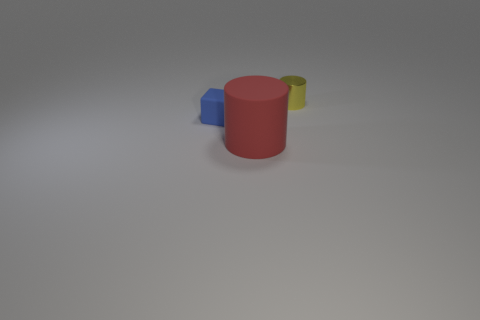What shape is the small thing in front of the small object to the right of the rubber object that is right of the blue block?
Provide a succinct answer. Cube. Is there another tiny yellow thing that has the same material as the small yellow thing?
Ensure brevity in your answer.  No. There is a rubber thing left of the large red rubber thing; does it have the same color as the tiny thing on the right side of the large red object?
Your answer should be compact. No. Are there fewer yellow shiny things in front of the large thing than cubes?
Your answer should be very brief. Yes. How many objects are big matte cylinders or cylinders to the left of the tiny yellow metallic cylinder?
Offer a very short reply. 1. What color is the tiny block that is the same material as the big red cylinder?
Provide a short and direct response. Blue. How many objects are green matte objects or small yellow metal things?
Your answer should be very brief. 1. There is another rubber thing that is the same size as the yellow object; what color is it?
Give a very brief answer. Blue. What number of things are objects that are left of the shiny thing or blocks?
Make the answer very short. 2. What number of other objects are there of the same size as the metallic thing?
Offer a terse response. 1. 